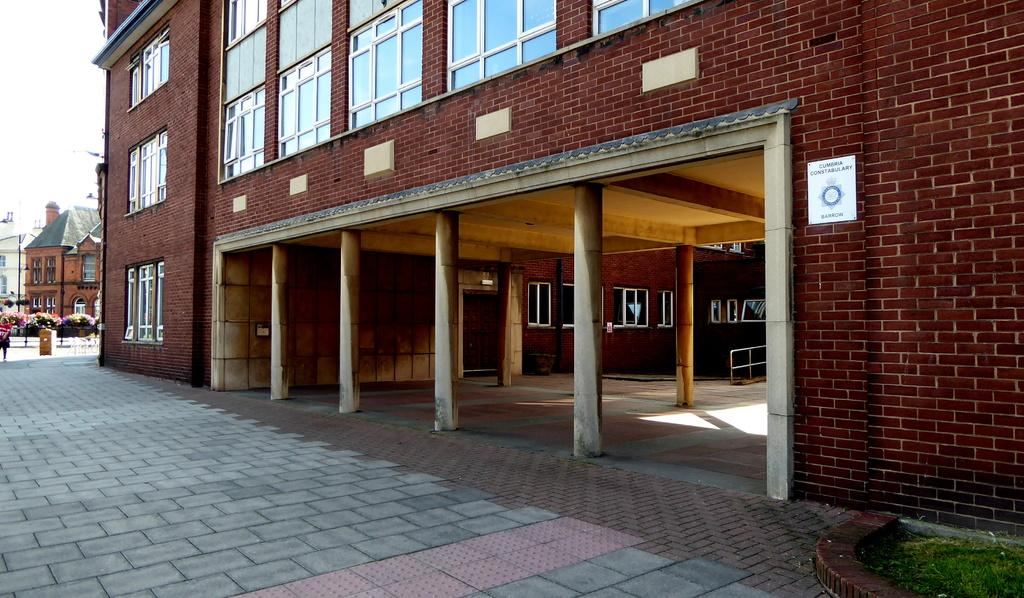What type of structures are present in the image? There are buildings in the image. Can you describe the color of one of the buildings? One building is in brown color. What feature can be seen on the building? There are glass windows on the building. What can be seen in the background of the image? There are flowers in multicolor in the background of the image. Where is the giraffe standing in the image? There is no giraffe present in the image. What type of bottle can be seen on the building? There is no bottle visible on the building in the image. 